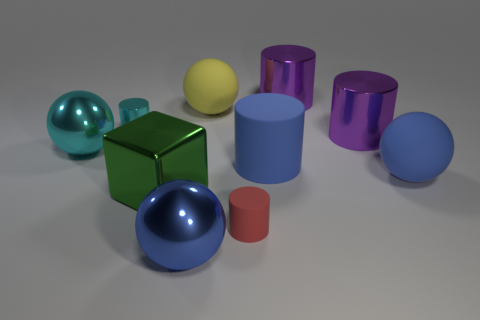Subtract 1 cylinders. How many cylinders are left? 4 Subtract all cyan cylinders. How many cylinders are left? 4 Subtract all blue cylinders. How many cylinders are left? 4 Subtract all yellow cylinders. Subtract all purple spheres. How many cylinders are left? 5 Subtract all cubes. How many objects are left? 9 Subtract 0 gray cylinders. How many objects are left? 10 Subtract all small red objects. Subtract all small green matte things. How many objects are left? 9 Add 7 small matte cylinders. How many small matte cylinders are left? 8 Add 5 small purple things. How many small purple things exist? 5 